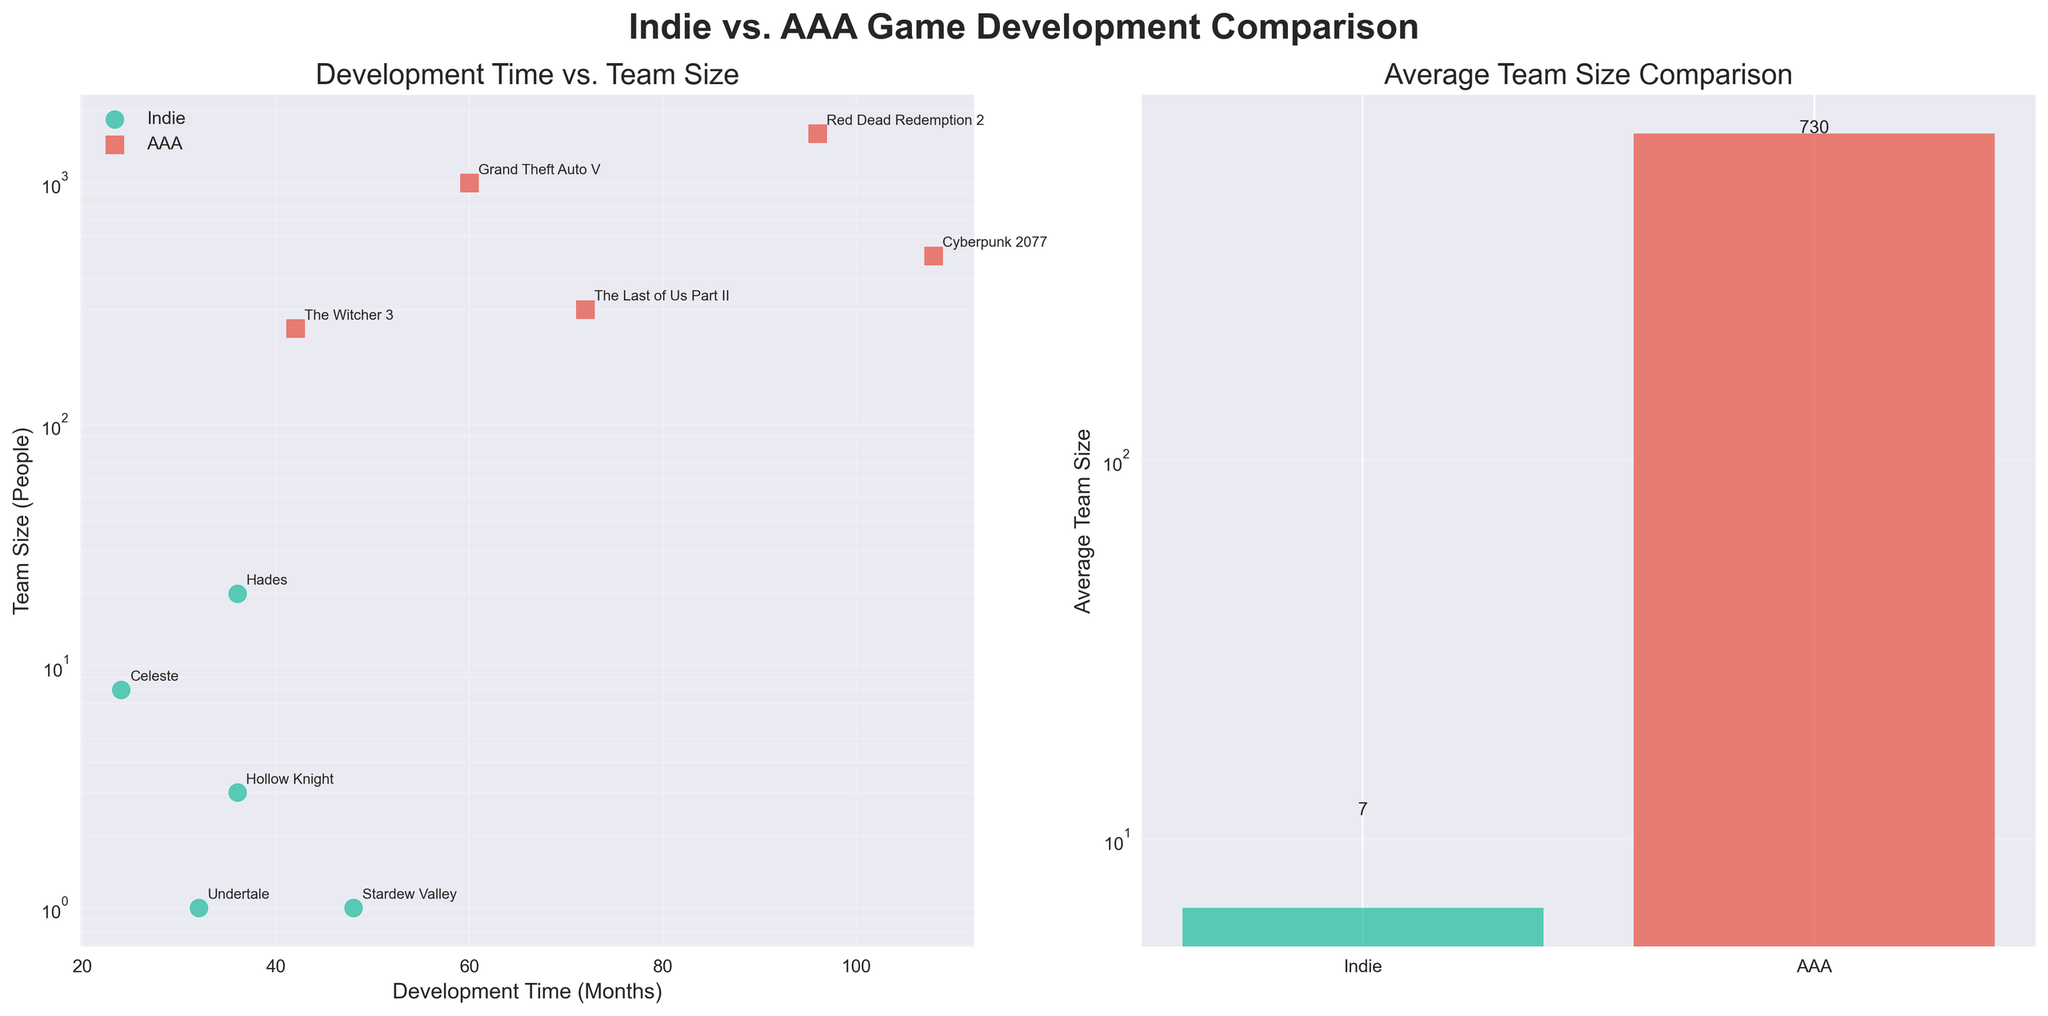What are the titles of the two subplots? The titles are displayed at the top of each subplot. The left subplot is titled "Development Time vs. Team Size," and the right subplot is titled "Average Team Size Comparison."
Answer: Development Time vs. Team Size, Average Team Size Comparison How are the team sizes of indie and AAA games visually represented in the Development Time vs. Team Size subplot? In the Development Time vs. Team Size subplot, indie game team sizes are represented by green circles, while AAA game team sizes are represented by red squares.
Answer: Green circles and red squares What is the average team size for indie games? The average team size for indie games can be seen from the right subplot "Average Team Size Comparison," where the height of the green bar indicates the average team size.
Answer: Approximately 7 How many data points represent indie games in the Development Time vs. Team Size subplot? By counting the green circles in the Development Time vs. Team Size subplot, we can see that there are 5 data points representing indie games.
Answer: 5 Which game has the longest development time, and what team size does it have? By looking at the x-axis and the annotations in the Development Time vs. Team Size subplot, we can identify that "Cyberpunk 2077" has the longest development time of 108 months and a team size of 500 people.
Answer: Cyberpunk 2077, 500 How do the average team sizes of indie and AAA games compare? The right subplot "Average Team Size Comparison" shows that the average team size for AAA games (represented by the red bar) is significantly larger than for indie games (green bar).
Answer: AAA is much larger Is there any indie game with a development time close to an AAA game? In the Development Time vs. Team Size subplot, "Hades" (an indie game) has a development time of 36 months, which is close to "The Witcher 3" (an AAA game) with a development time of 42 months.
Answer: Hades and The Witcher 3 What is the team size difference between the game with the largest and the smallest team size? From the subplot "Development Time vs. Team Size," the game with the largest team size is "Red Dead Redemption 2" with 1600 people, and the smallest is "Stardew Valley" with 1 person. The difference is 1600 - 1.
Answer: 1599 What's the range of development times for indie games? The development times for indie games can be seen from the x-axis points of the green circles. The values range from 24 months (Celeste) to 48 months (Stardew Valley).
Answer: 24 to 48 months What is the relationship between development time and team size for AAA games? Observing the pattern in the Development Time vs. Team Size subplot, there tends to be a loose positive relationship where longer development times often correlate with larger team sizes among AAA games.
Answer: Positive correlation 